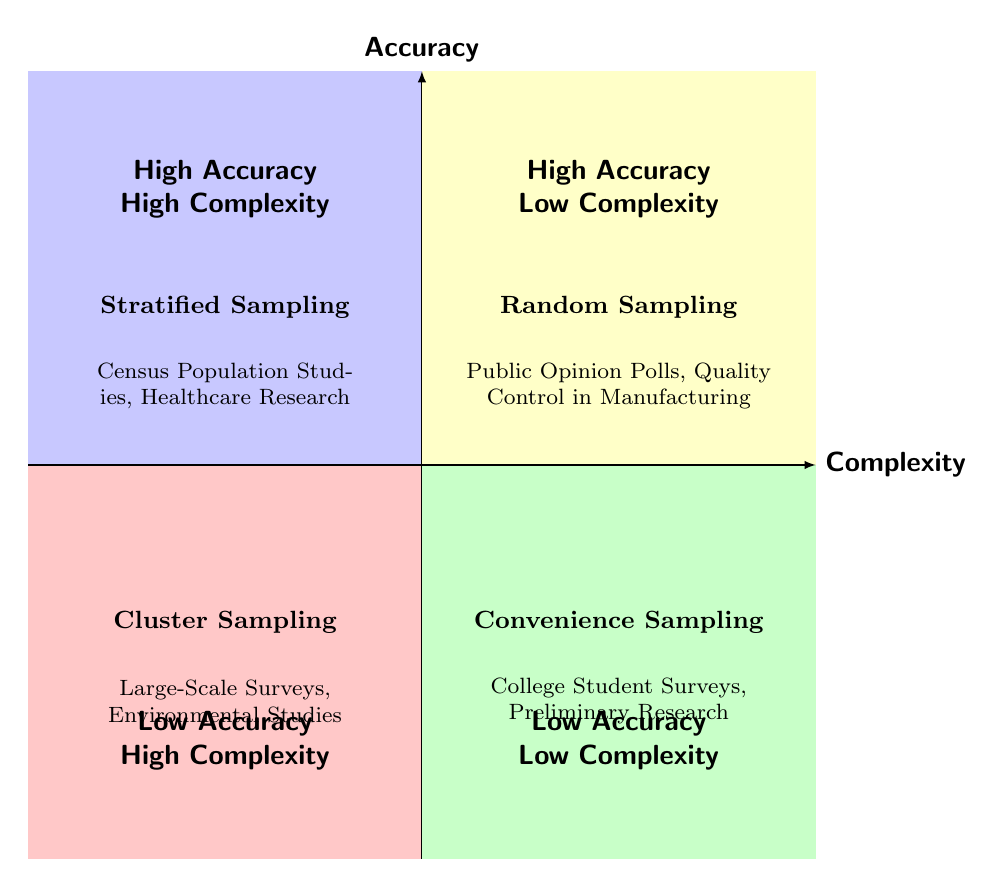What sampling technique is in Q1? Q1 corresponds to the "High Accuracy - High Complexity" category, where the sampling technique listed is "Stratified Sampling".
Answer: Stratified Sampling What are the advantages of Random Sampling? The quadrant for Random Sampling (Q2) lists two advantages: "Simplicity in Implementation" and "Good Generalizability".
Answer: Simplicity in Implementation, Good Generalizability Which sampling technique has low accuracy and high complexity? Q3 represents "Low Accuracy - High Complexity", which is associated with "Cluster Sampling".
Answer: Cluster Sampling What are the examples for Convenience Sampling? In Q4, which is the "Low Accuracy - Low Complexity" quadrant, the examples given are "College Student Surveys" and "Preliminary Research".
Answer: College Student Surveys, Preliminary Research How many quadrants are displayed in the chart? The chart is divided into four quadrants: Q1, Q2, Q3, and Q4, indicating a total of four sections showing different aspects of sampling techniques and their effectiveness.
Answer: Four What are the disadvantages of Stratified Sampling? The description in Q1 outlines two disadvantages of Stratified Sampling: "Complex Implementation" and "Requires Detailed Population Information".
Answer: Complex Implementation, Requires Detailed Population Information Which quadrant would likely have the highest sampling bias? Q4, labeled "Low Accuracy - Low Complexity", lists "Convenience Sampling", which is known for having high sampling bias.
Answer: Q4 Why is Cluster Sampling cost-effective for large populations? Q3 explains that Cluster Sampling is "Cost-Effective for Large Populations" due to its ability to simplify logistics, thus reducing overall costs when dealing with large samples.
Answer: Cost-Effective for Large Populations 